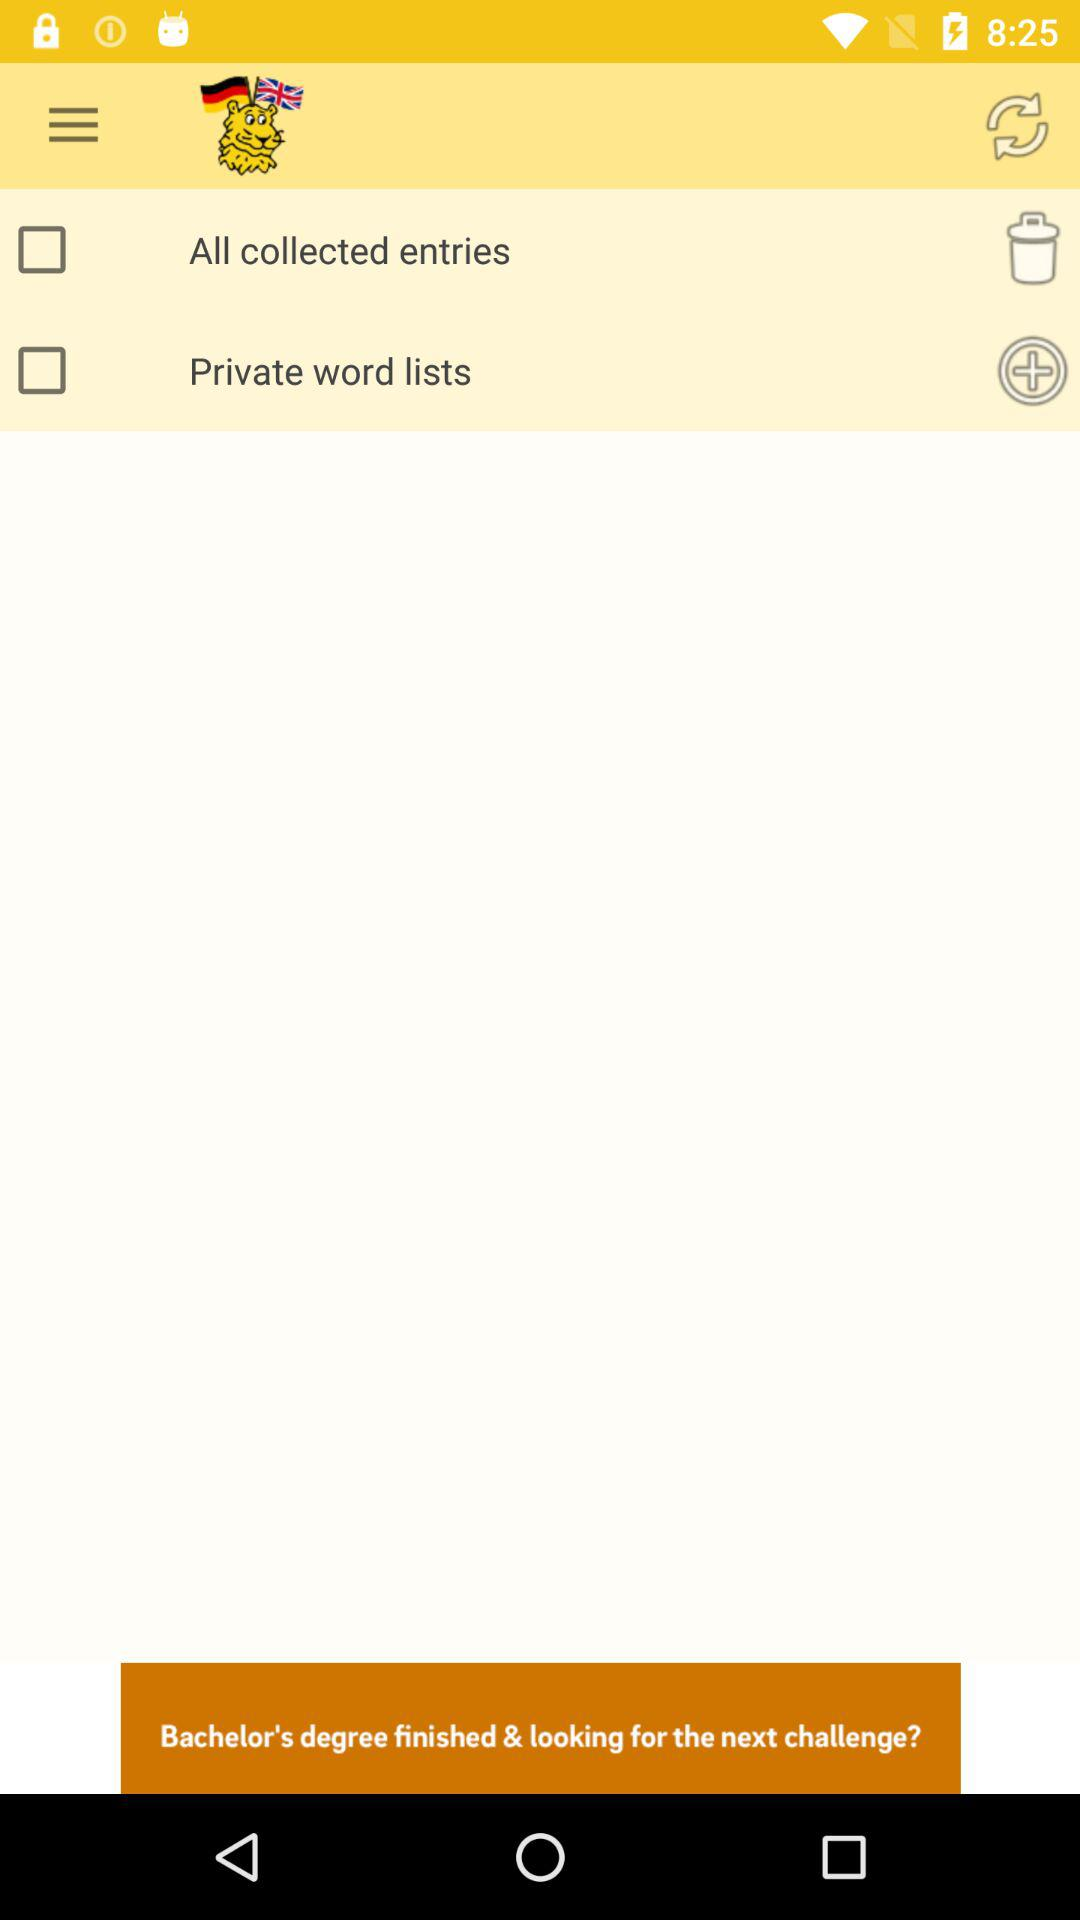What is the status of the "Private word lists"? The status is "off". 